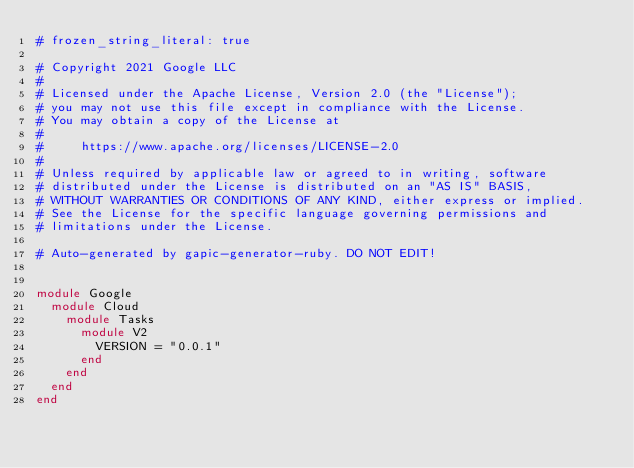<code> <loc_0><loc_0><loc_500><loc_500><_Ruby_># frozen_string_literal: true

# Copyright 2021 Google LLC
#
# Licensed under the Apache License, Version 2.0 (the "License");
# you may not use this file except in compliance with the License.
# You may obtain a copy of the License at
#
#     https://www.apache.org/licenses/LICENSE-2.0
#
# Unless required by applicable law or agreed to in writing, software
# distributed under the License is distributed on an "AS IS" BASIS,
# WITHOUT WARRANTIES OR CONDITIONS OF ANY KIND, either express or implied.
# See the License for the specific language governing permissions and
# limitations under the License.

# Auto-generated by gapic-generator-ruby. DO NOT EDIT!


module Google
  module Cloud
    module Tasks
      module V2
        VERSION = "0.0.1"
      end
    end
  end
end
</code> 